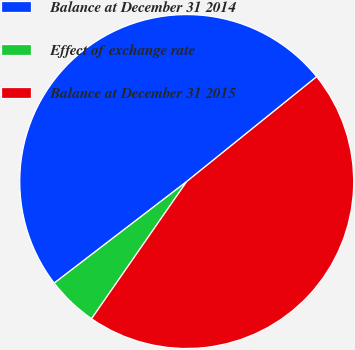Convert chart. <chart><loc_0><loc_0><loc_500><loc_500><pie_chart><fcel>Balance at December 31 2014<fcel>Effect of exchange rate<fcel>Balance at December 31 2015<nl><fcel>49.6%<fcel>4.94%<fcel>45.45%<nl></chart> 